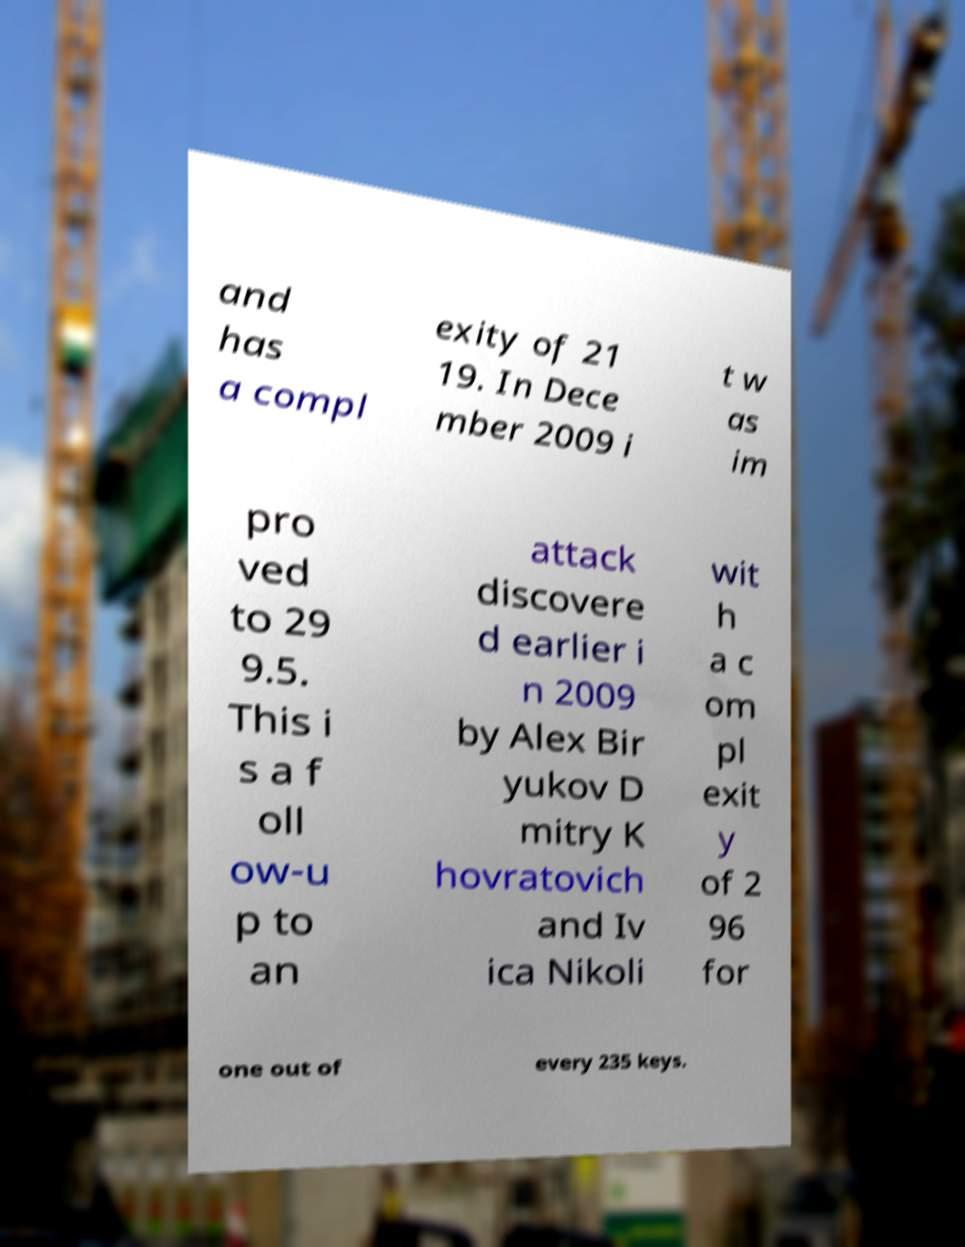Could you assist in decoding the text presented in this image and type it out clearly? and has a compl exity of 21 19. In Dece mber 2009 i t w as im pro ved to 29 9.5. This i s a f oll ow-u p to an attack discovere d earlier i n 2009 by Alex Bir yukov D mitry K hovratovich and Iv ica Nikoli wit h a c om pl exit y of 2 96 for one out of every 235 keys. 